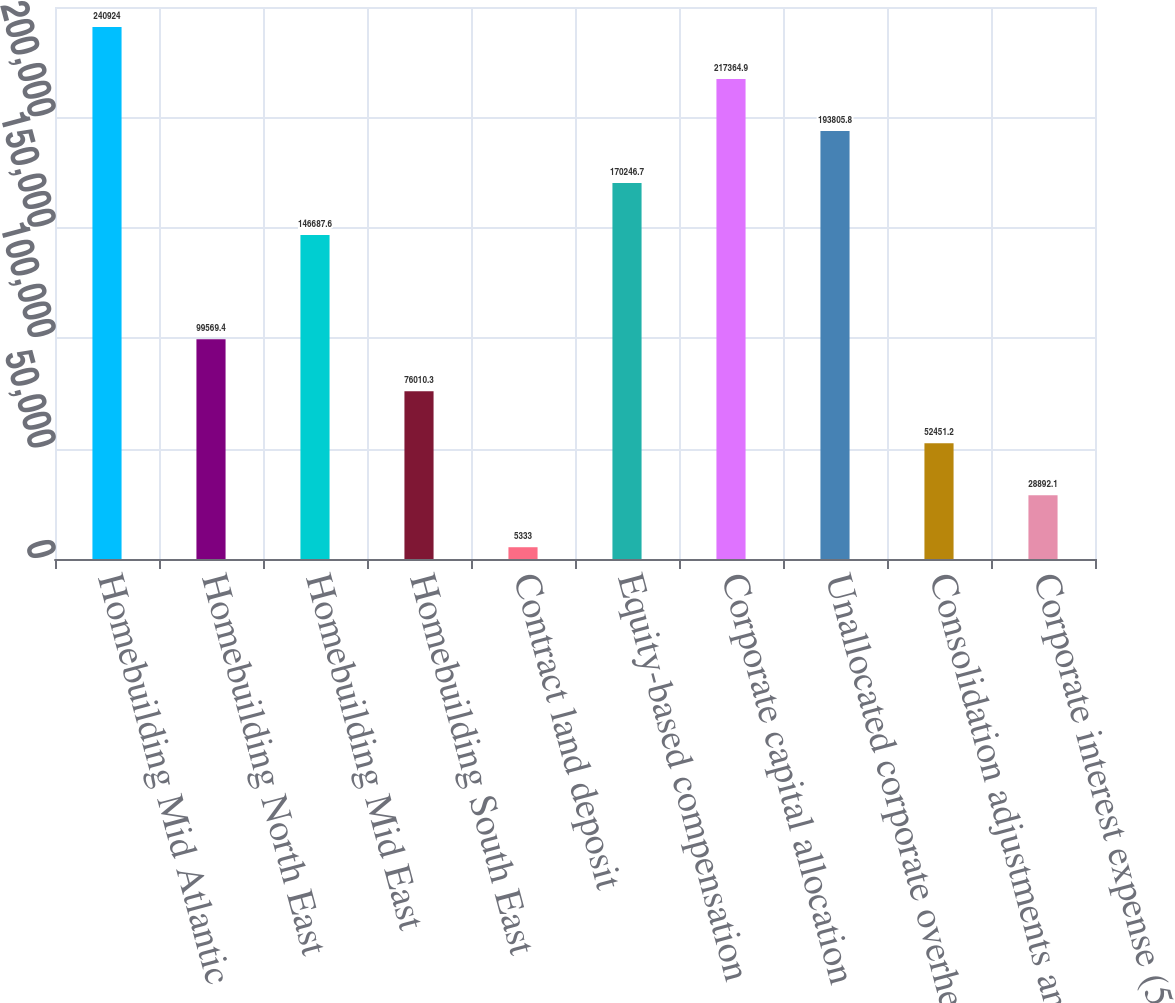<chart> <loc_0><loc_0><loc_500><loc_500><bar_chart><fcel>Homebuilding Mid Atlantic<fcel>Homebuilding North East<fcel>Homebuilding Mid East<fcel>Homebuilding South East<fcel>Contract land deposit<fcel>Equity-based compensation<fcel>Corporate capital allocation<fcel>Unallocated corporate overhead<fcel>Consolidation adjustments and<fcel>Corporate interest expense (5)<nl><fcel>240924<fcel>99569.4<fcel>146688<fcel>76010.3<fcel>5333<fcel>170247<fcel>217365<fcel>193806<fcel>52451.2<fcel>28892.1<nl></chart> 